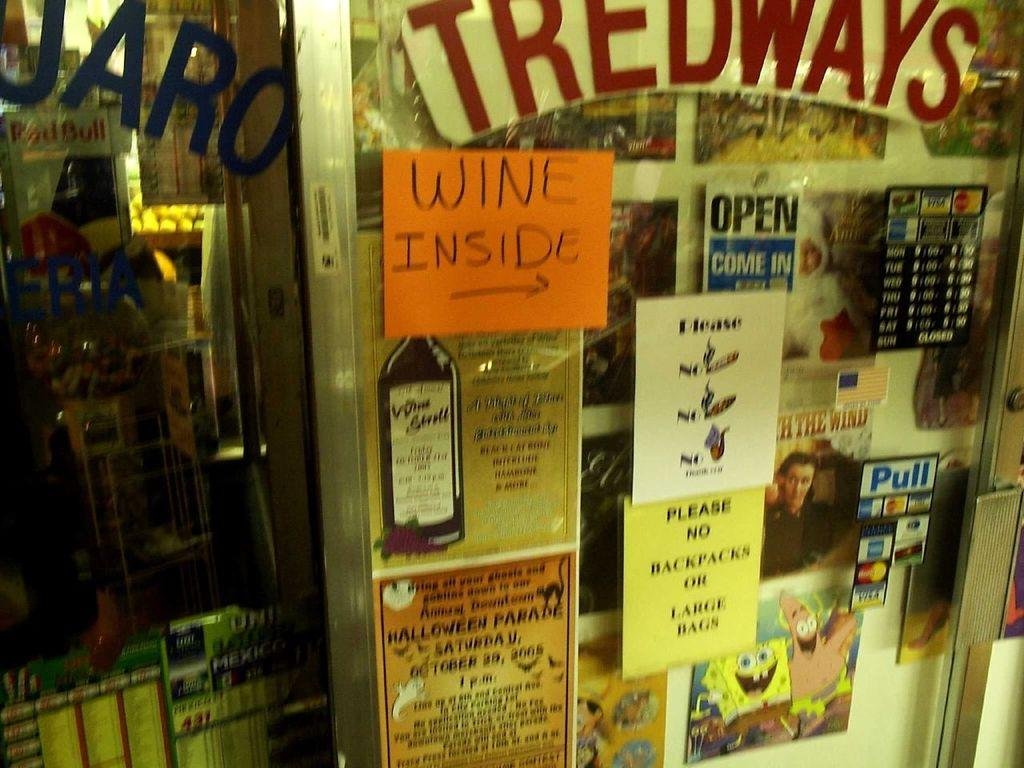<image>
Write a terse but informative summary of the picture. store named tredways  that is open and orange paper with words wine inside written on it 